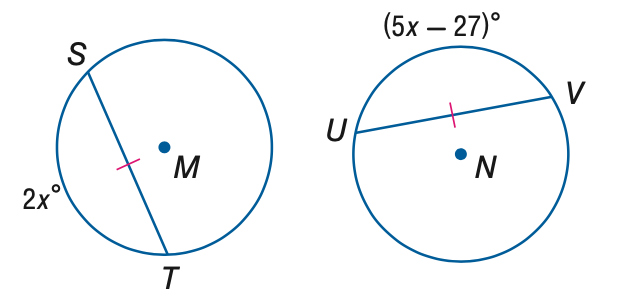Question: Find x if \odot M \cong \odot N.
Choices:
A. 8
B. 9
C. 10
D. 12
Answer with the letter. Answer: B 